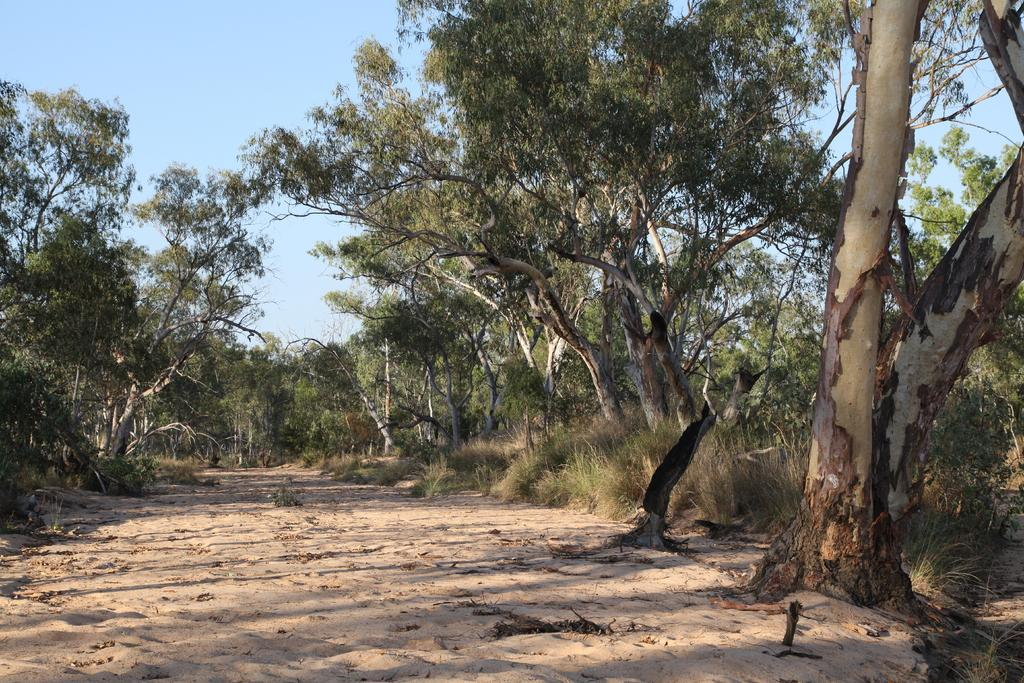What is the main subject of the image? The main subject of the image is a road. Where is the road located in the image? The road is at the center of the image. What can be seen in the background of the image? There are trees and the sky visible in the background of the image. How much jelly is required to fill the road in the image? There is no jelly present in the image, so it cannot be filled with jelly. 